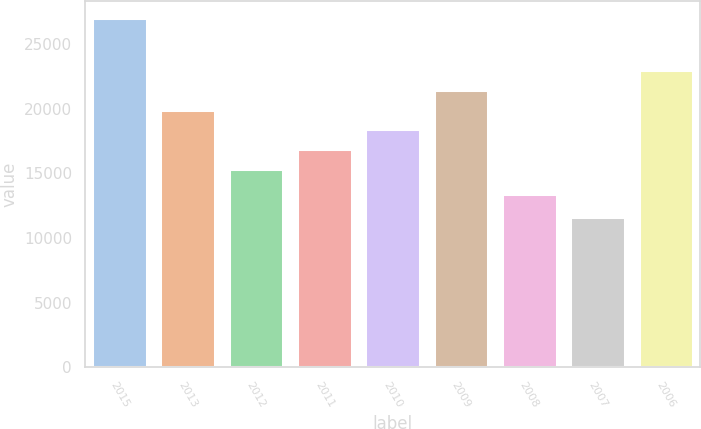Convert chart to OTSL. <chart><loc_0><loc_0><loc_500><loc_500><bar_chart><fcel>2015<fcel>2013<fcel>2012<fcel>2011<fcel>2010<fcel>2009<fcel>2008<fcel>2007<fcel>2006<nl><fcel>26987<fcel>19926.1<fcel>15319<fcel>16854.7<fcel>18390.4<fcel>21461.8<fcel>13424<fcel>11630<fcel>22997.5<nl></chart> 